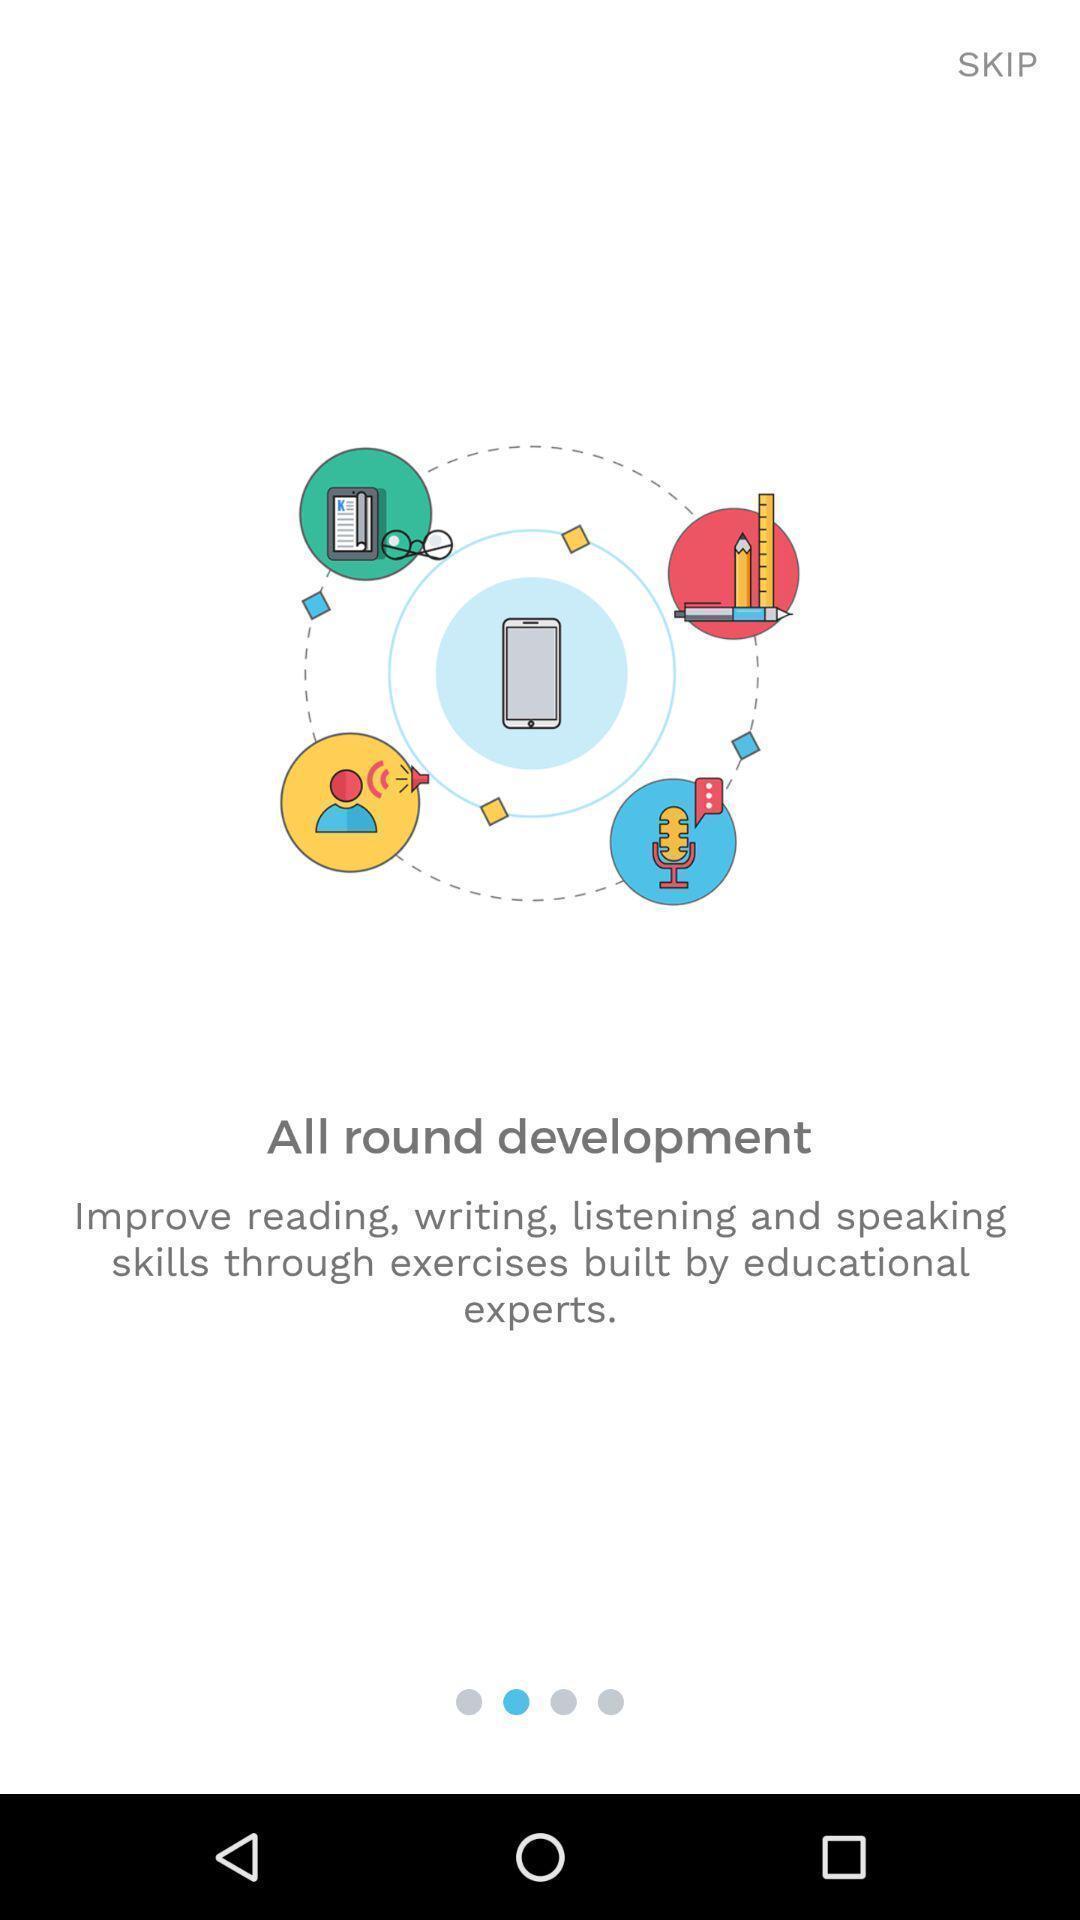Describe the key features of this screenshot. Welcome page. 